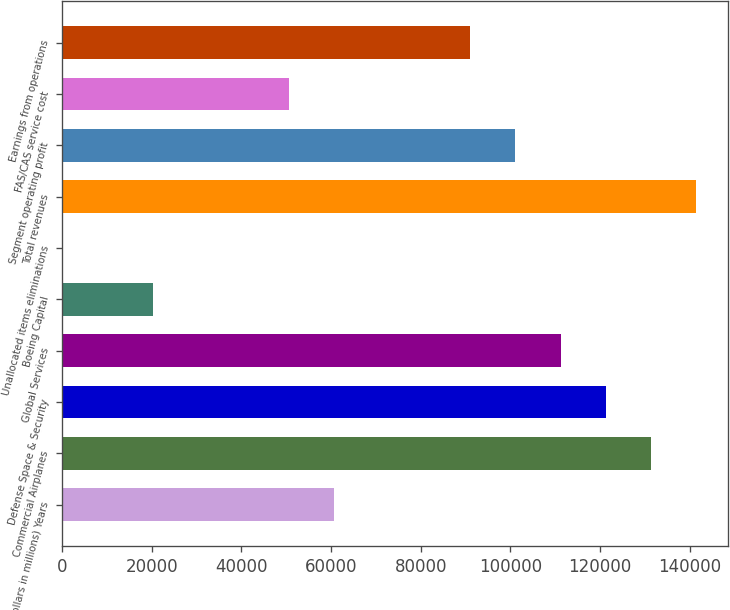Convert chart to OTSL. <chart><loc_0><loc_0><loc_500><loc_500><bar_chart><fcel>(Dollars in millions) Years<fcel>Commercial Airplanes<fcel>Defense Space & Security<fcel>Global Services<fcel>Boeing Capital<fcel>Unallocated items eliminations<fcel>Total revenues<fcel>Segment operating profit<fcel>FAS/CAS service cost<fcel>Earnings from operations<nl><fcel>60706.2<fcel>131443<fcel>121337<fcel>111232<fcel>20285.4<fcel>75<fcel>141548<fcel>101127<fcel>50601<fcel>91021.8<nl></chart> 